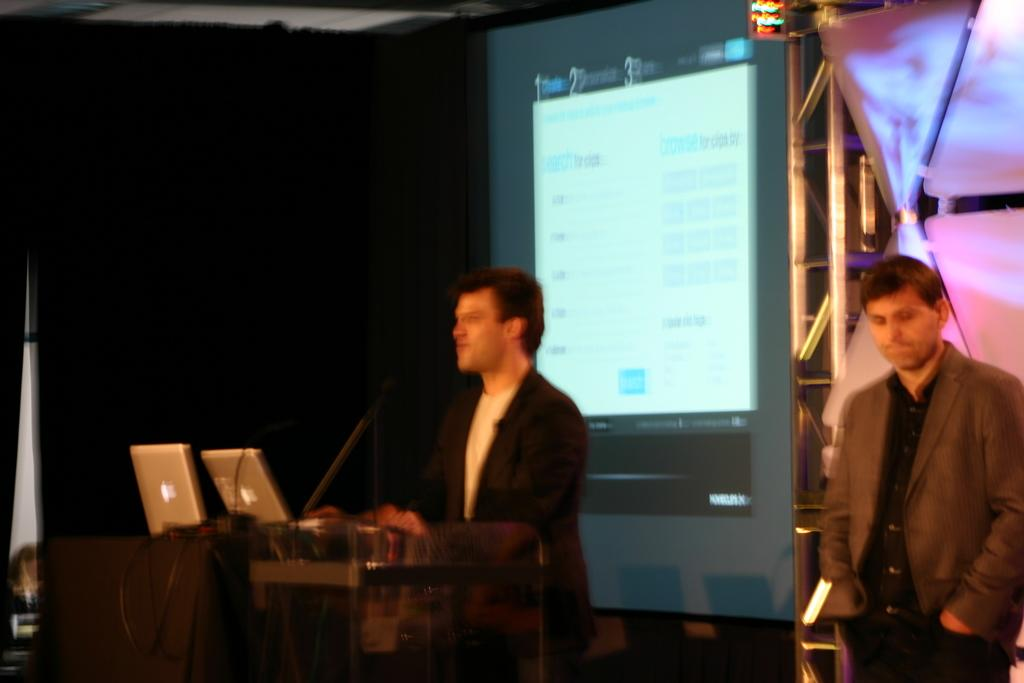How many people are in the image? There are two persons in the image. What can be seen on the podium in the image? There are Macs and laptops on the podium. What is the purpose of the podium in the image? The podium is likely used for presentations or speeches. What is the screen in the image used for? The screen in the image is likely used for displaying information or visuals. What type of calendar is hanging on the wall behind the podium? There is no calendar visible in the image. What color are the clouds in the image? There are no clouds present in the image. 